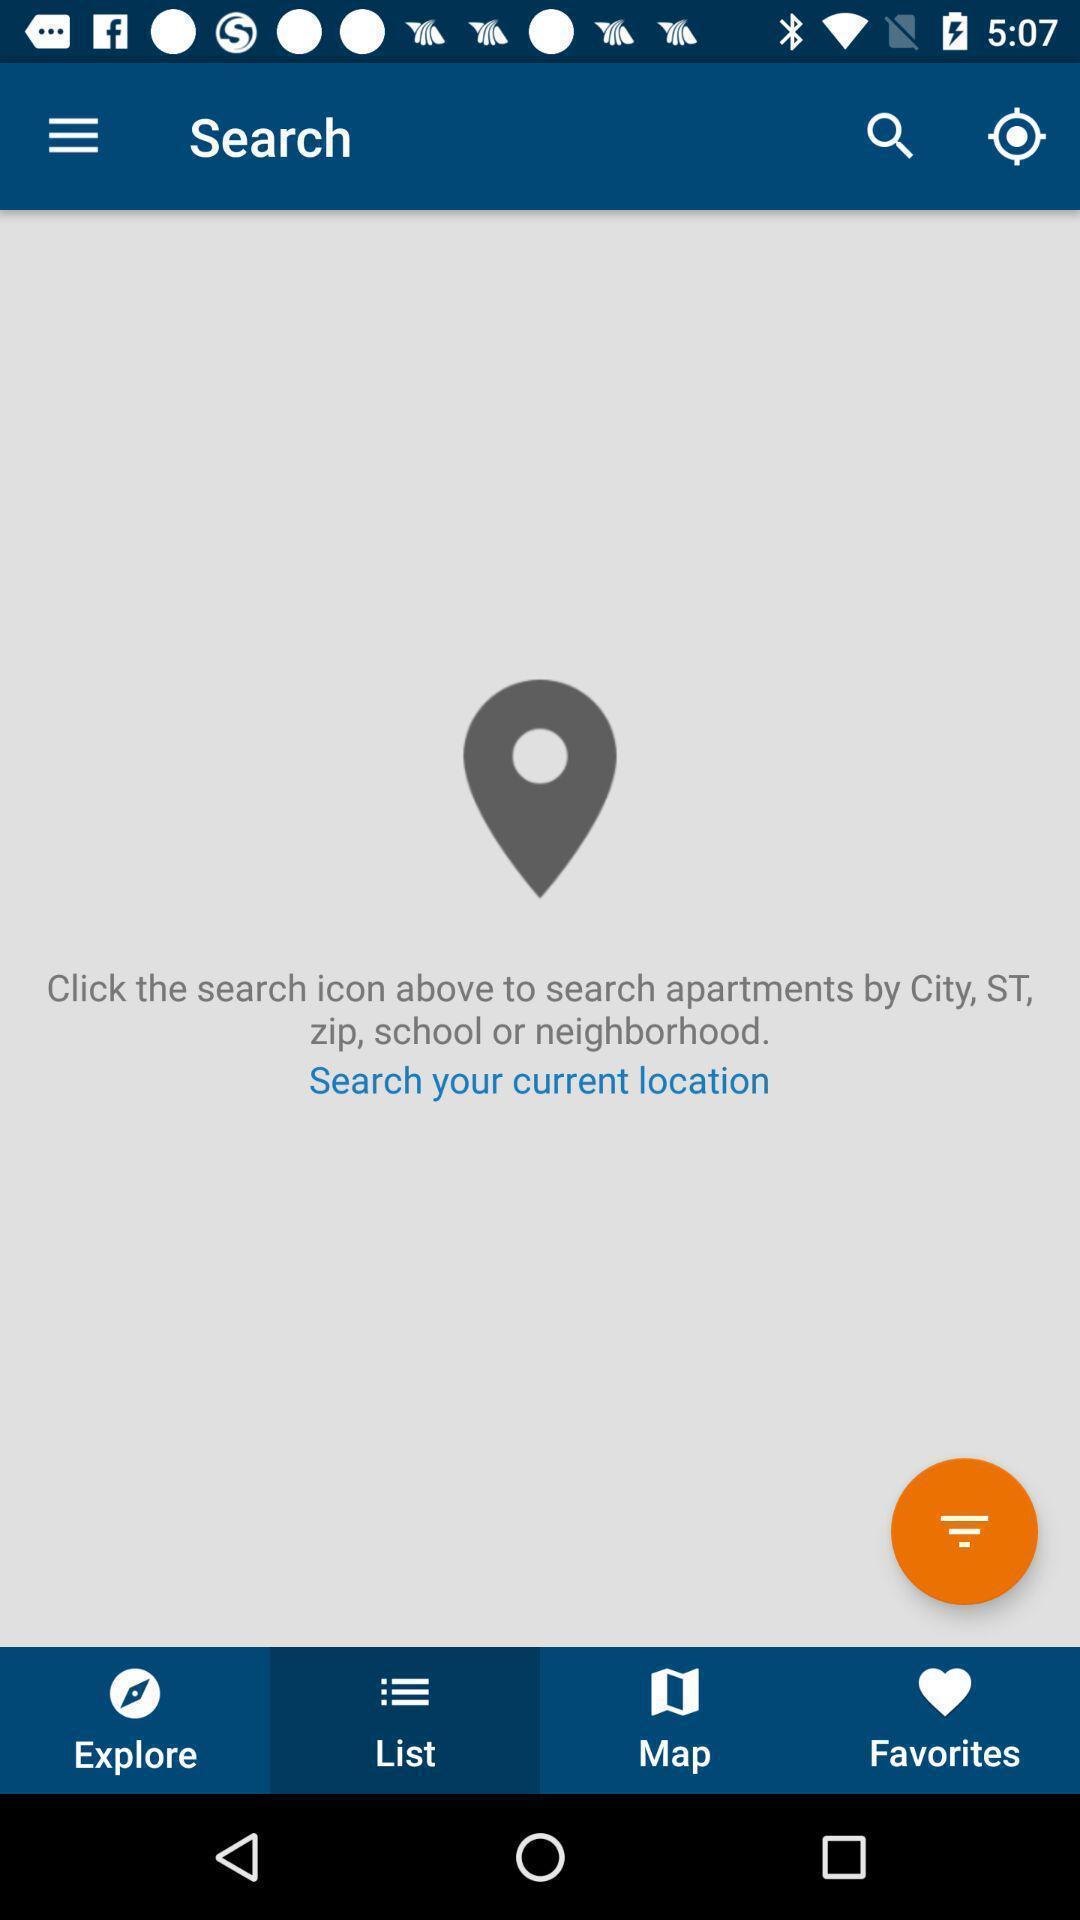Summarize the main components in this picture. Search page to find the current location. 